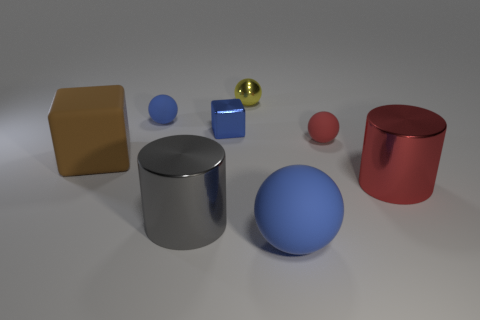There is a tiny shiny object that is the same color as the large rubber sphere; what shape is it?
Your answer should be compact. Cube. What size is the blue rubber thing that is behind the rubber object in front of the brown matte object?
Keep it short and to the point. Small. Do the big rubber thing to the right of the tiny blue rubber object and the red matte thing that is right of the large blue matte object have the same shape?
Your answer should be very brief. Yes. Are there the same number of matte objects to the left of the gray thing and blue blocks?
Your answer should be very brief. No. There is a big matte thing that is the same shape as the blue shiny object; what color is it?
Keep it short and to the point. Brown. Are the blue thing in front of the big matte block and the brown thing made of the same material?
Keep it short and to the point. Yes. How many big things are either purple metal blocks or red balls?
Provide a succinct answer. 0. How big is the red cylinder?
Make the answer very short. Large. There is a red rubber object; is its size the same as the yellow shiny sphere that is on the right side of the gray metallic cylinder?
Give a very brief answer. Yes. How many yellow objects are either tiny spheres or big shiny objects?
Make the answer very short. 1. 